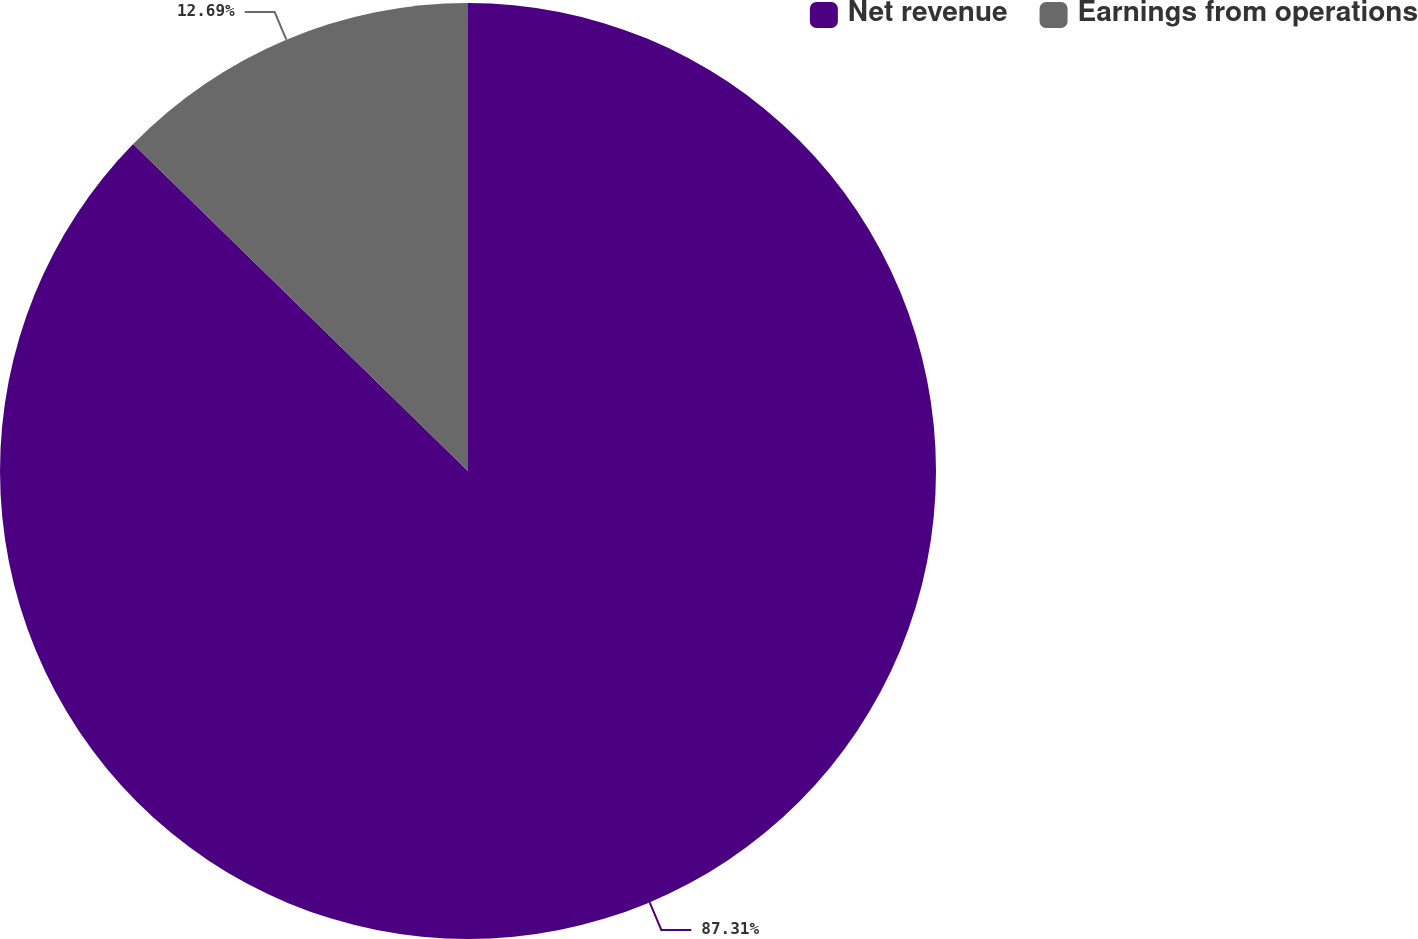Convert chart to OTSL. <chart><loc_0><loc_0><loc_500><loc_500><pie_chart><fcel>Net revenue<fcel>Earnings from operations<nl><fcel>87.31%<fcel>12.69%<nl></chart> 